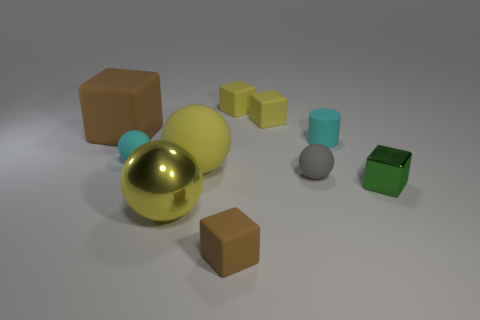Subtract all green blocks. How many blocks are left? 4 Subtract all large cubes. How many cubes are left? 4 Subtract 1 blocks. How many blocks are left? 4 Subtract all red blocks. Subtract all purple cylinders. How many blocks are left? 5 Subtract all balls. How many objects are left? 6 Subtract all tiny green cubes. Subtract all gray shiny cubes. How many objects are left? 9 Add 4 large yellow metallic spheres. How many large yellow metallic spheres are left? 5 Add 5 gray matte things. How many gray matte things exist? 6 Subtract 0 purple cylinders. How many objects are left? 10 